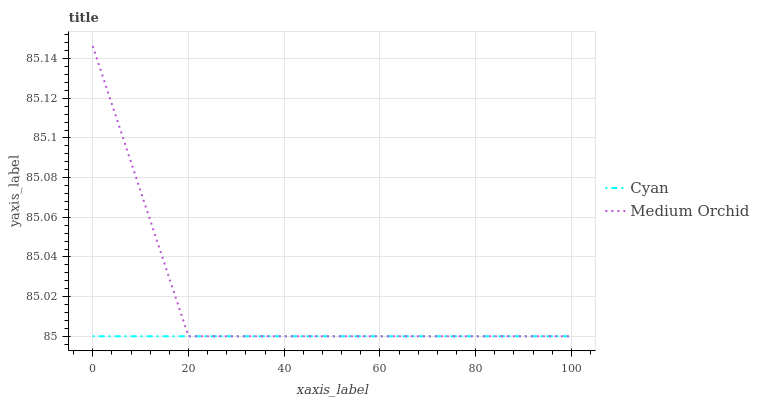Does Cyan have the minimum area under the curve?
Answer yes or no. Yes. Does Medium Orchid have the maximum area under the curve?
Answer yes or no. Yes. Does Medium Orchid have the minimum area under the curve?
Answer yes or no. No. Is Cyan the smoothest?
Answer yes or no. Yes. Is Medium Orchid the roughest?
Answer yes or no. Yes. Is Medium Orchid the smoothest?
Answer yes or no. No. Does Cyan have the lowest value?
Answer yes or no. Yes. Does Medium Orchid have the highest value?
Answer yes or no. Yes. Does Cyan intersect Medium Orchid?
Answer yes or no. Yes. Is Cyan less than Medium Orchid?
Answer yes or no. No. Is Cyan greater than Medium Orchid?
Answer yes or no. No. 